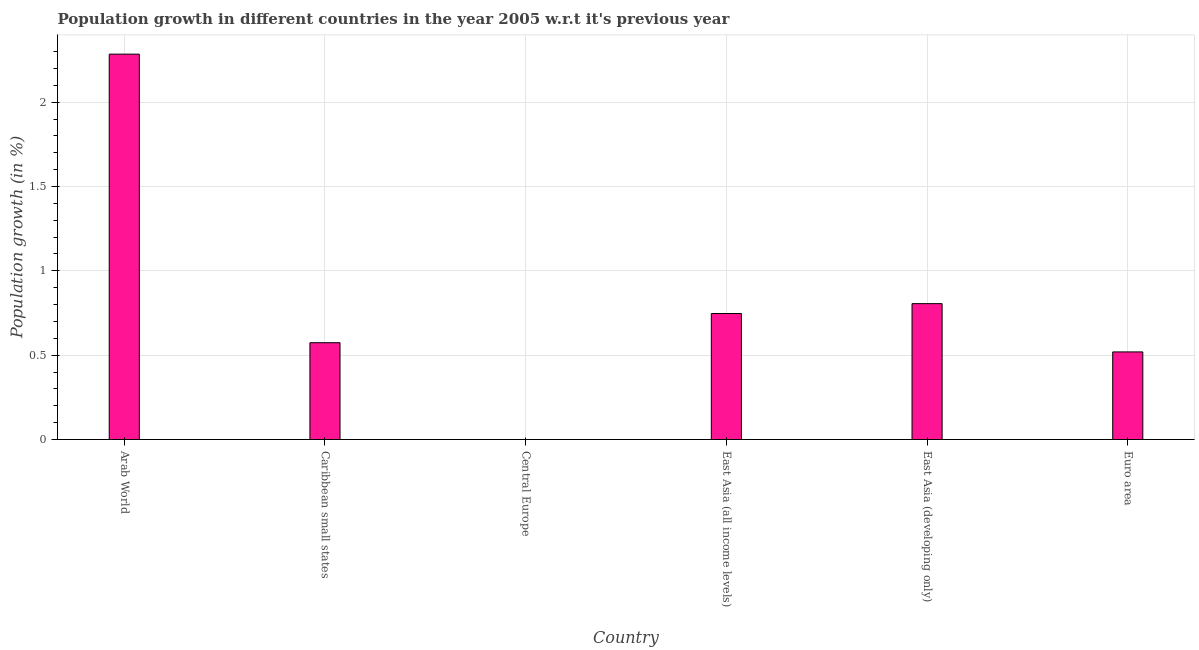What is the title of the graph?
Ensure brevity in your answer.  Population growth in different countries in the year 2005 w.r.t it's previous year. What is the label or title of the Y-axis?
Give a very brief answer. Population growth (in %). What is the population growth in East Asia (developing only)?
Offer a terse response. 0.81. Across all countries, what is the maximum population growth?
Make the answer very short. 2.28. Across all countries, what is the minimum population growth?
Keep it short and to the point. 0. In which country was the population growth maximum?
Give a very brief answer. Arab World. What is the sum of the population growth?
Ensure brevity in your answer.  4.93. What is the difference between the population growth in Arab World and Euro area?
Provide a succinct answer. 1.76. What is the average population growth per country?
Provide a succinct answer. 0.82. What is the median population growth?
Give a very brief answer. 0.66. In how many countries, is the population growth greater than 2 %?
Provide a succinct answer. 1. What is the ratio of the population growth in East Asia (all income levels) to that in Euro area?
Keep it short and to the point. 1.44. Is the difference between the population growth in Arab World and Caribbean small states greater than the difference between any two countries?
Offer a terse response. No. What is the difference between the highest and the second highest population growth?
Provide a short and direct response. 1.48. Is the sum of the population growth in East Asia (all income levels) and Euro area greater than the maximum population growth across all countries?
Ensure brevity in your answer.  No. What is the difference between the highest and the lowest population growth?
Give a very brief answer. 2.28. Are all the bars in the graph horizontal?
Your response must be concise. No. Are the values on the major ticks of Y-axis written in scientific E-notation?
Make the answer very short. No. What is the Population growth (in %) in Arab World?
Your answer should be very brief. 2.28. What is the Population growth (in %) of Caribbean small states?
Your answer should be compact. 0.57. What is the Population growth (in %) in East Asia (all income levels)?
Ensure brevity in your answer.  0.75. What is the Population growth (in %) in East Asia (developing only)?
Offer a terse response. 0.81. What is the Population growth (in %) of Euro area?
Ensure brevity in your answer.  0.52. What is the difference between the Population growth (in %) in Arab World and Caribbean small states?
Provide a succinct answer. 1.71. What is the difference between the Population growth (in %) in Arab World and East Asia (all income levels)?
Offer a terse response. 1.54. What is the difference between the Population growth (in %) in Arab World and East Asia (developing only)?
Provide a short and direct response. 1.48. What is the difference between the Population growth (in %) in Arab World and Euro area?
Provide a succinct answer. 1.77. What is the difference between the Population growth (in %) in Caribbean small states and East Asia (all income levels)?
Your answer should be compact. -0.17. What is the difference between the Population growth (in %) in Caribbean small states and East Asia (developing only)?
Ensure brevity in your answer.  -0.23. What is the difference between the Population growth (in %) in Caribbean small states and Euro area?
Your answer should be very brief. 0.05. What is the difference between the Population growth (in %) in East Asia (all income levels) and East Asia (developing only)?
Ensure brevity in your answer.  -0.06. What is the difference between the Population growth (in %) in East Asia (all income levels) and Euro area?
Your response must be concise. 0.23. What is the difference between the Population growth (in %) in East Asia (developing only) and Euro area?
Ensure brevity in your answer.  0.29. What is the ratio of the Population growth (in %) in Arab World to that in Caribbean small states?
Your response must be concise. 3.98. What is the ratio of the Population growth (in %) in Arab World to that in East Asia (all income levels)?
Provide a succinct answer. 3.06. What is the ratio of the Population growth (in %) in Arab World to that in East Asia (developing only)?
Provide a succinct answer. 2.84. What is the ratio of the Population growth (in %) in Arab World to that in Euro area?
Provide a short and direct response. 4.4. What is the ratio of the Population growth (in %) in Caribbean small states to that in East Asia (all income levels)?
Your response must be concise. 0.77. What is the ratio of the Population growth (in %) in Caribbean small states to that in East Asia (developing only)?
Your response must be concise. 0.71. What is the ratio of the Population growth (in %) in Caribbean small states to that in Euro area?
Your answer should be compact. 1.1. What is the ratio of the Population growth (in %) in East Asia (all income levels) to that in East Asia (developing only)?
Provide a succinct answer. 0.93. What is the ratio of the Population growth (in %) in East Asia (all income levels) to that in Euro area?
Ensure brevity in your answer.  1.44. What is the ratio of the Population growth (in %) in East Asia (developing only) to that in Euro area?
Provide a succinct answer. 1.55. 